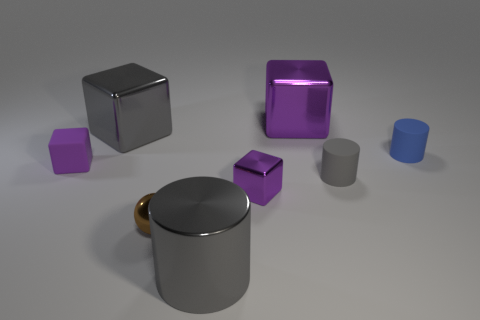Subtract all purple balls. How many purple cubes are left? 3 Subtract all yellow cubes. Subtract all yellow spheres. How many cubes are left? 4 Add 1 tiny purple shiny things. How many objects exist? 9 Subtract all balls. How many objects are left? 7 Subtract all spheres. Subtract all small objects. How many objects are left? 2 Add 8 rubber cylinders. How many rubber cylinders are left? 10 Add 2 tiny brown spheres. How many tiny brown spheres exist? 3 Subtract 0 cyan cubes. How many objects are left? 8 